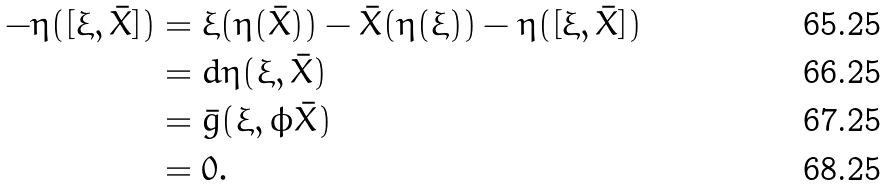Convert formula to latex. <formula><loc_0><loc_0><loc_500><loc_500>- \eta ( [ \xi , \bar { X } ] ) & = \xi ( \eta ( \bar { X } ) ) - \bar { X } ( \eta ( \xi ) ) - \eta ( [ \xi , \bar { X } ] ) \\ & = d \eta ( \xi , \bar { X } ) \\ & = \bar { g } ( \xi , \phi \bar { X } ) \\ & = 0 .</formula> 